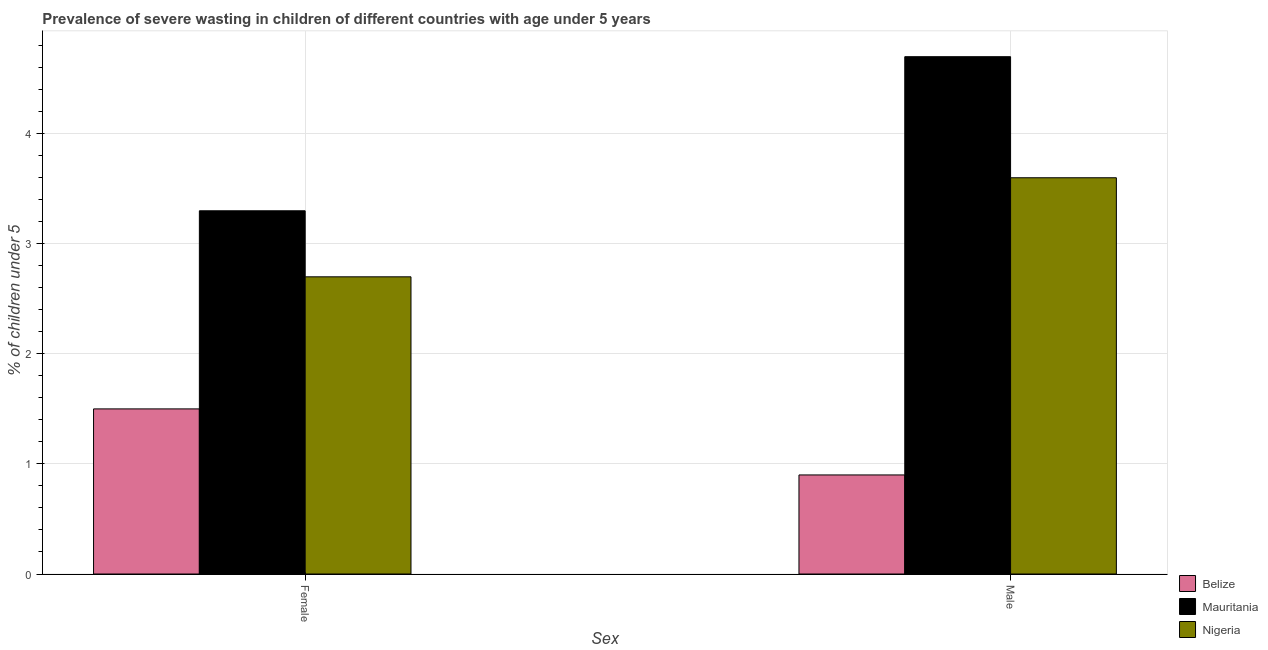How many groups of bars are there?
Your answer should be compact. 2. How many bars are there on the 2nd tick from the left?
Your answer should be compact. 3. How many bars are there on the 2nd tick from the right?
Provide a short and direct response. 3. What is the percentage of undernourished female children in Nigeria?
Give a very brief answer. 2.7. Across all countries, what is the maximum percentage of undernourished male children?
Your response must be concise. 4.7. In which country was the percentage of undernourished female children maximum?
Offer a very short reply. Mauritania. In which country was the percentage of undernourished female children minimum?
Your answer should be very brief. Belize. What is the total percentage of undernourished male children in the graph?
Ensure brevity in your answer.  9.2. What is the difference between the percentage of undernourished female children in Nigeria and that in Mauritania?
Give a very brief answer. -0.6. What is the difference between the percentage of undernourished male children in Mauritania and the percentage of undernourished female children in Belize?
Ensure brevity in your answer.  3.2. What is the average percentage of undernourished male children per country?
Keep it short and to the point. 3.07. What is the difference between the percentage of undernourished male children and percentage of undernourished female children in Mauritania?
Ensure brevity in your answer.  1.4. In how many countries, is the percentage of undernourished female children greater than 3.8 %?
Ensure brevity in your answer.  0. What is the ratio of the percentage of undernourished male children in Mauritania to that in Nigeria?
Make the answer very short. 1.31. In how many countries, is the percentage of undernourished female children greater than the average percentage of undernourished female children taken over all countries?
Provide a short and direct response. 2. What does the 3rd bar from the left in Female represents?
Offer a terse response. Nigeria. What does the 1st bar from the right in Male represents?
Offer a very short reply. Nigeria. Are all the bars in the graph horizontal?
Provide a short and direct response. No. What is the difference between two consecutive major ticks on the Y-axis?
Give a very brief answer. 1. Are the values on the major ticks of Y-axis written in scientific E-notation?
Your answer should be very brief. No. Does the graph contain grids?
Your answer should be very brief. Yes. How are the legend labels stacked?
Ensure brevity in your answer.  Vertical. What is the title of the graph?
Your answer should be compact. Prevalence of severe wasting in children of different countries with age under 5 years. What is the label or title of the X-axis?
Ensure brevity in your answer.  Sex. What is the label or title of the Y-axis?
Offer a terse response.  % of children under 5. What is the  % of children under 5 in Belize in Female?
Ensure brevity in your answer.  1.5. What is the  % of children under 5 in Mauritania in Female?
Offer a terse response. 3.3. What is the  % of children under 5 in Nigeria in Female?
Offer a very short reply. 2.7. What is the  % of children under 5 in Belize in Male?
Make the answer very short. 0.9. What is the  % of children under 5 in Mauritania in Male?
Give a very brief answer. 4.7. What is the  % of children under 5 in Nigeria in Male?
Your response must be concise. 3.6. Across all Sex, what is the maximum  % of children under 5 of Mauritania?
Provide a short and direct response. 4.7. Across all Sex, what is the maximum  % of children under 5 of Nigeria?
Your answer should be very brief. 3.6. Across all Sex, what is the minimum  % of children under 5 of Belize?
Keep it short and to the point. 0.9. Across all Sex, what is the minimum  % of children under 5 of Mauritania?
Ensure brevity in your answer.  3.3. Across all Sex, what is the minimum  % of children under 5 in Nigeria?
Keep it short and to the point. 2.7. What is the difference between the  % of children under 5 of Belize in Female and that in Male?
Your answer should be very brief. 0.6. What is the difference between the  % of children under 5 in Belize in Female and the  % of children under 5 in Nigeria in Male?
Your answer should be compact. -2.1. What is the average  % of children under 5 of Mauritania per Sex?
Provide a succinct answer. 4. What is the average  % of children under 5 of Nigeria per Sex?
Your answer should be compact. 3.15. What is the difference between the  % of children under 5 of Belize and  % of children under 5 of Mauritania in Female?
Your response must be concise. -1.8. What is the difference between the  % of children under 5 in Mauritania and  % of children under 5 in Nigeria in Female?
Offer a very short reply. 0.6. What is the difference between the  % of children under 5 of Belize and  % of children under 5 of Mauritania in Male?
Provide a short and direct response. -3.8. What is the ratio of the  % of children under 5 in Mauritania in Female to that in Male?
Your response must be concise. 0.7. What is the ratio of the  % of children under 5 in Nigeria in Female to that in Male?
Your answer should be compact. 0.75. What is the difference between the highest and the second highest  % of children under 5 of Belize?
Your answer should be very brief. 0.6. What is the difference between the highest and the second highest  % of children under 5 of Mauritania?
Offer a terse response. 1.4. What is the difference between the highest and the lowest  % of children under 5 of Belize?
Keep it short and to the point. 0.6. What is the difference between the highest and the lowest  % of children under 5 in Mauritania?
Make the answer very short. 1.4. 